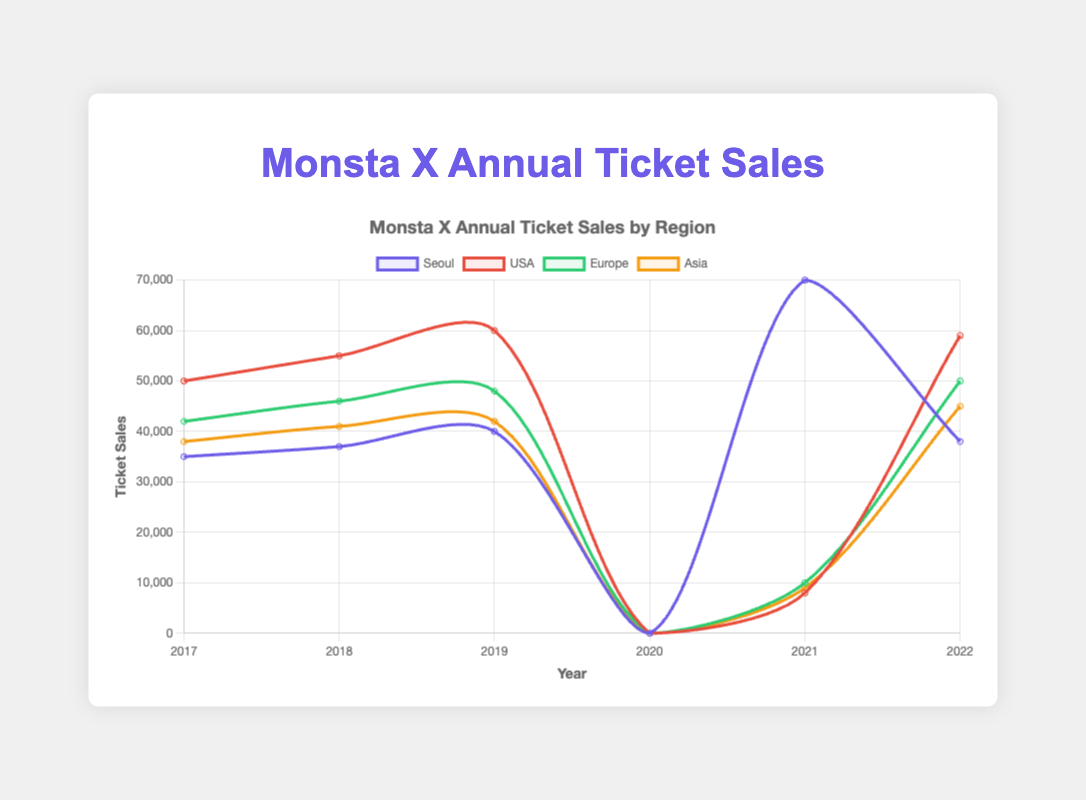What was the total number of tickets sold for Monsta X concerts in Seoul from 2017 to 2022, excluding 2020? Add the number of tickets sold each year for Seoul and exclude 2020: 35,000 + 37,000 + 40,000 + 8,000 + 38,000 = 158,000
Answer: 158,000 Which region had the highest ticket sales in the year 2017? Look at the 2017 data points and compare the numbers for each region: Seoul (35,000), USA (50,000), Europe (42,000), Asia (38,000); the USA has the highest.
Answer: USA How did the number of ticket sales in Europe change from 2019 to 2021? Check the data for Europe in 2019 (48,000) and 2021 (9,000) and calculate the difference: 48,000 - 9,000 = 39,000. The number decreased significantly.
Answer: Decreased by 39,000 What is the average number of tickets sold for the "No Limit World Tour" in 2022 across all regions? Add up the tickets sold in each region for the "No Limit World Tour" in 2022 and divide by the number of regions: (38,000 + 59,000 + 50,000 + 45,000)/4 = 48,000
Answer: 48,000 Which regions had more ticket sales in 2022 compared to 2019? Compare the ticket sales for each region in 2019 and 2022: Seoul (40,000 in 2019, 38,000 in 2022), USA (60,000 in 2019, 59,000 in 2022), Europe (48,000 in 2019, 50,000 in 2022), Asia (42,000 in 2019, 45,000 in 2022). Only Europe and Asia had more sales in 2022.
Answer: Europe and Asia Which year had the highest total ticket sales for Monsta X concerts in the USA? Look at the ticket sales data for the USA over the years: 2017 (50,000), 2018 (55,000), 2019 (60,000), 2021 (10,000), 2022 (59,000). The year 2019 had the highest sales.
Answer: 2019 In which year did Monsta X sell the fewest tickets in Seoul, excluding 2020? Compare the ticket sales in Seoul across the years, excluding 2020: 2017 (35,000), 2018 (37,000), 2019 (40,000), 2021 (8,000), 2022 (38,000). The fewest tickets were sold in 2021.
Answer: 2021 What was the total ticket sales for all Monsta X concerts in 2021? Add up the ticket sales for all regions in 2021: 70,000 (Online Concert) + 8,000 (Seoul) + 10,000 (USA) + 9,000 (Europe) + 6,000 (Asia) = 103,000
Answer: 103,000 How did ticket sales for Monsta X concerts in Asia change from 2018 to 2022? Compare the ticket sales in Asia between 2018 (41,000) and 2022 (45,000): 45,000 - 41,000 = 4,000 more tickets sold in 2022.
Answer: Increased by 4,000 